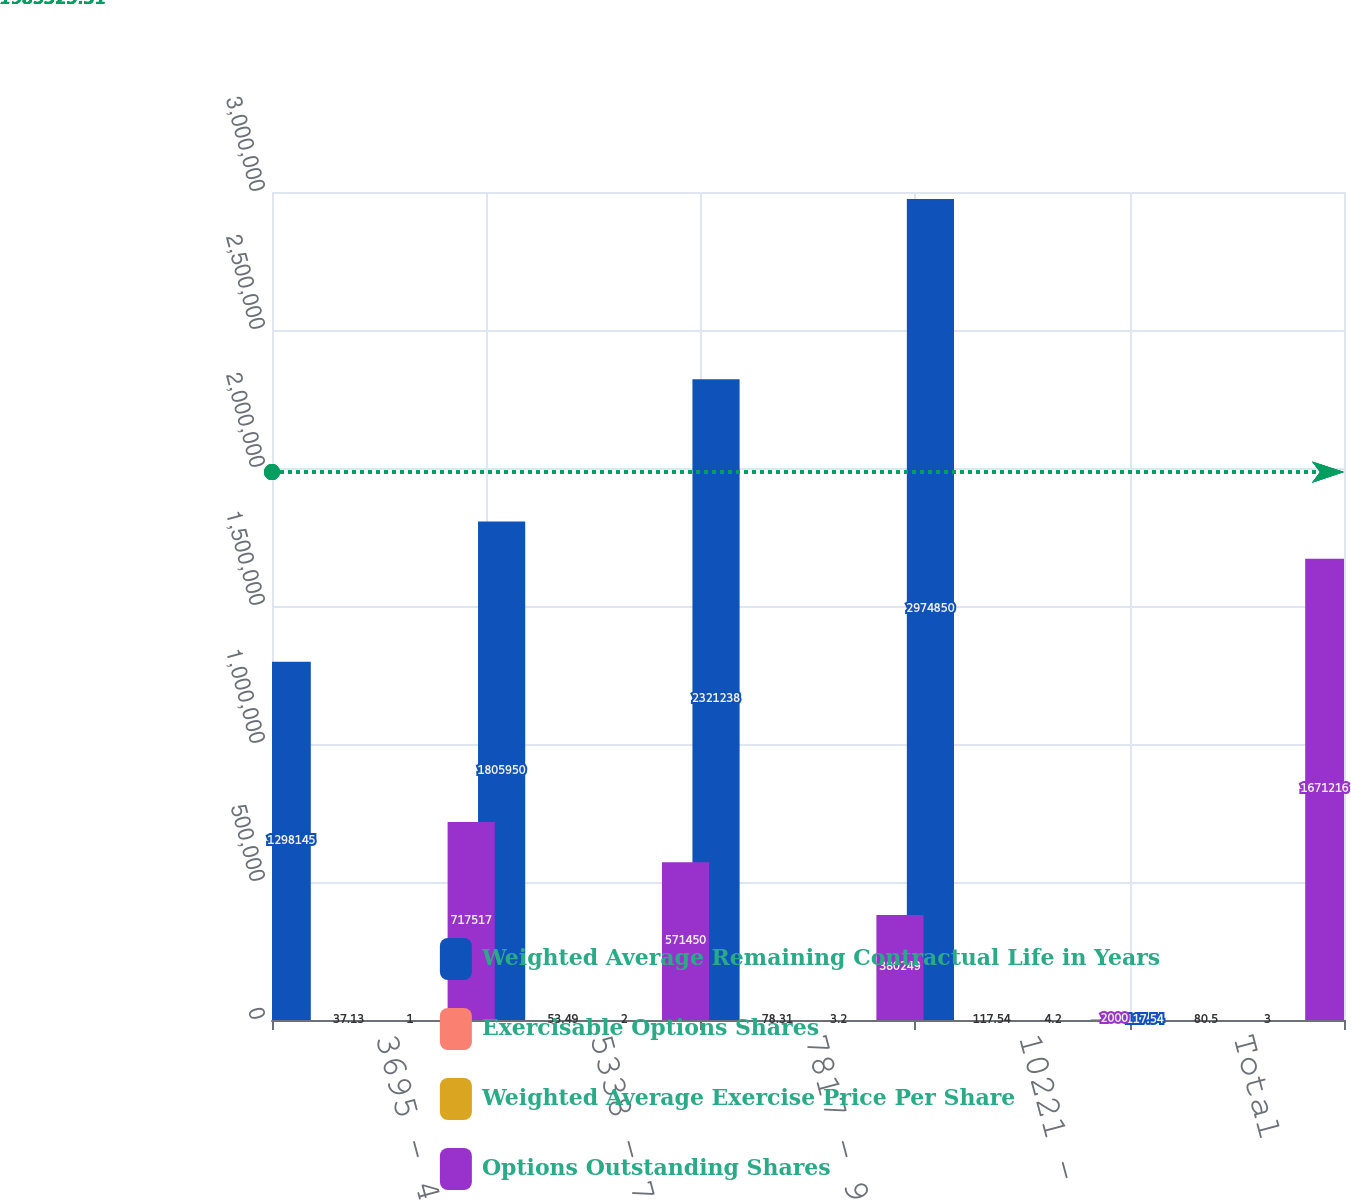Convert chart. <chart><loc_0><loc_0><loc_500><loc_500><stacked_bar_chart><ecel><fcel>3695 - 4697<fcel>5338 - 7365<fcel>7817 - 9698<fcel>10221 - 14243<fcel>Total<nl><fcel>Weighted Average Remaining Contractual Life in Years<fcel>1.29814e+06<fcel>1.80595e+06<fcel>2.32124e+06<fcel>2.97485e+06<fcel>117.54<nl><fcel>Exercisable Options Shares<fcel>37.13<fcel>53.49<fcel>78.31<fcel>117.54<fcel>80.5<nl><fcel>Weighted Average Exercise Price Per Share<fcel>1<fcel>2<fcel>3.2<fcel>4.2<fcel>3<nl><fcel>Options Outstanding Shares<fcel>717517<fcel>571450<fcel>380249<fcel>2000<fcel>1.67122e+06<nl></chart> 